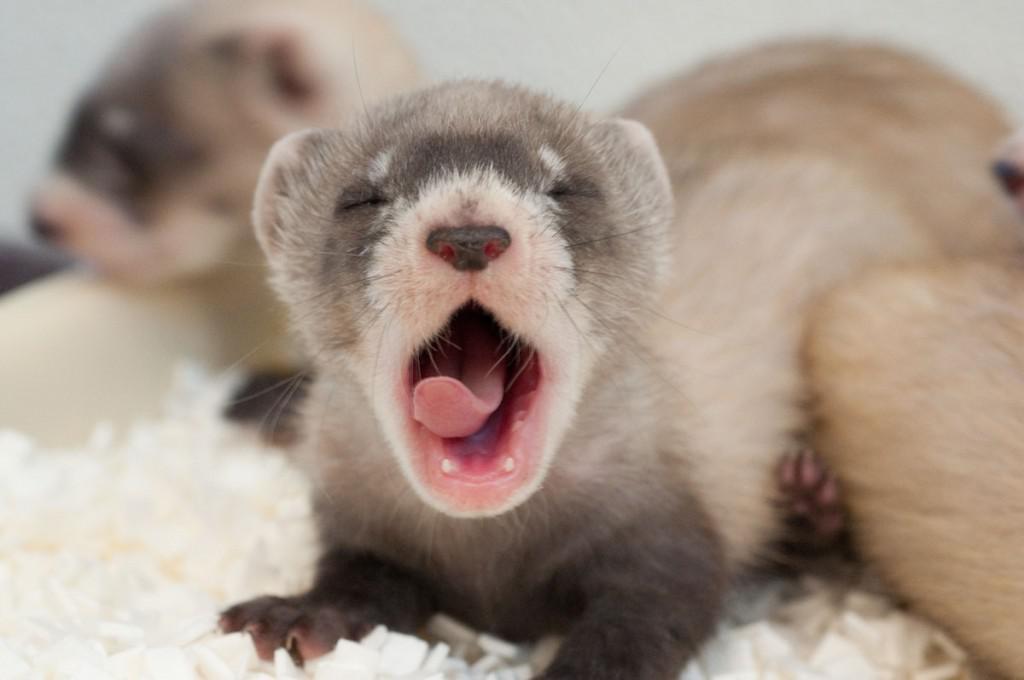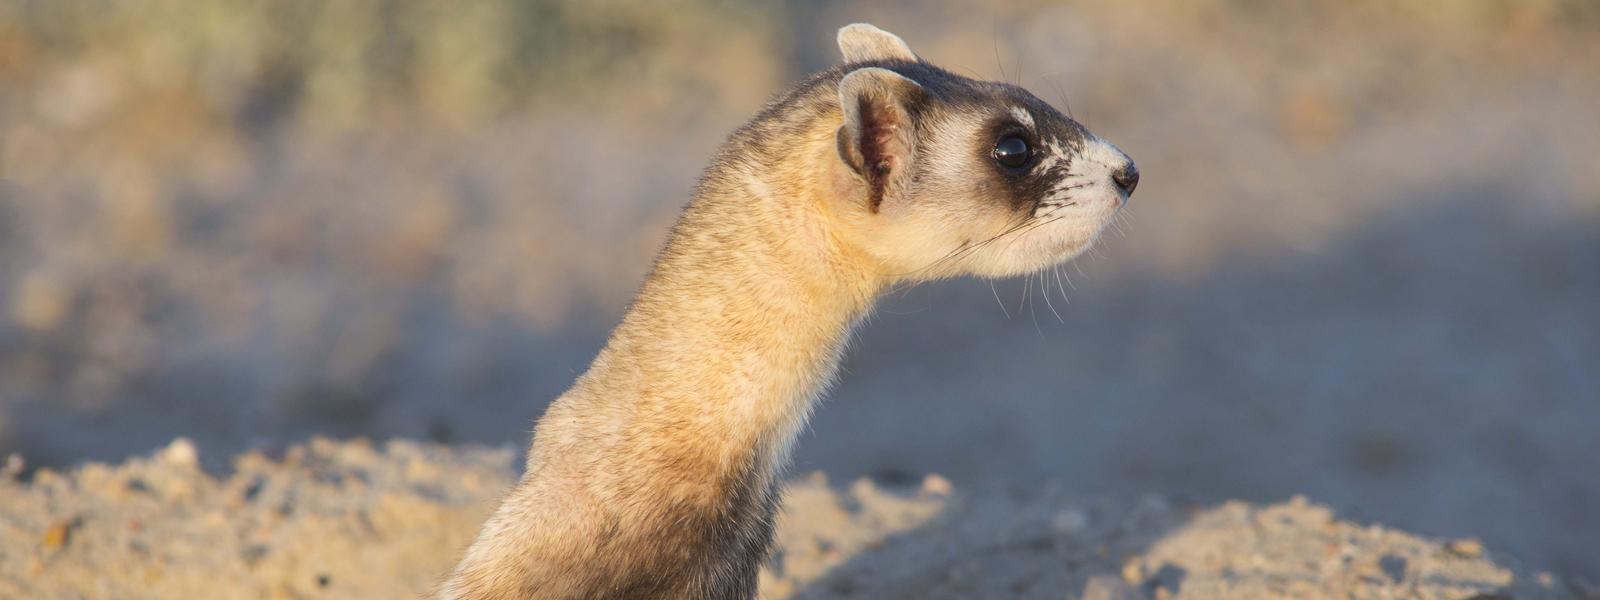The first image is the image on the left, the second image is the image on the right. For the images displayed, is the sentence "There are exactly two animals in the image on the left." factually correct? Answer yes or no. Yes. 